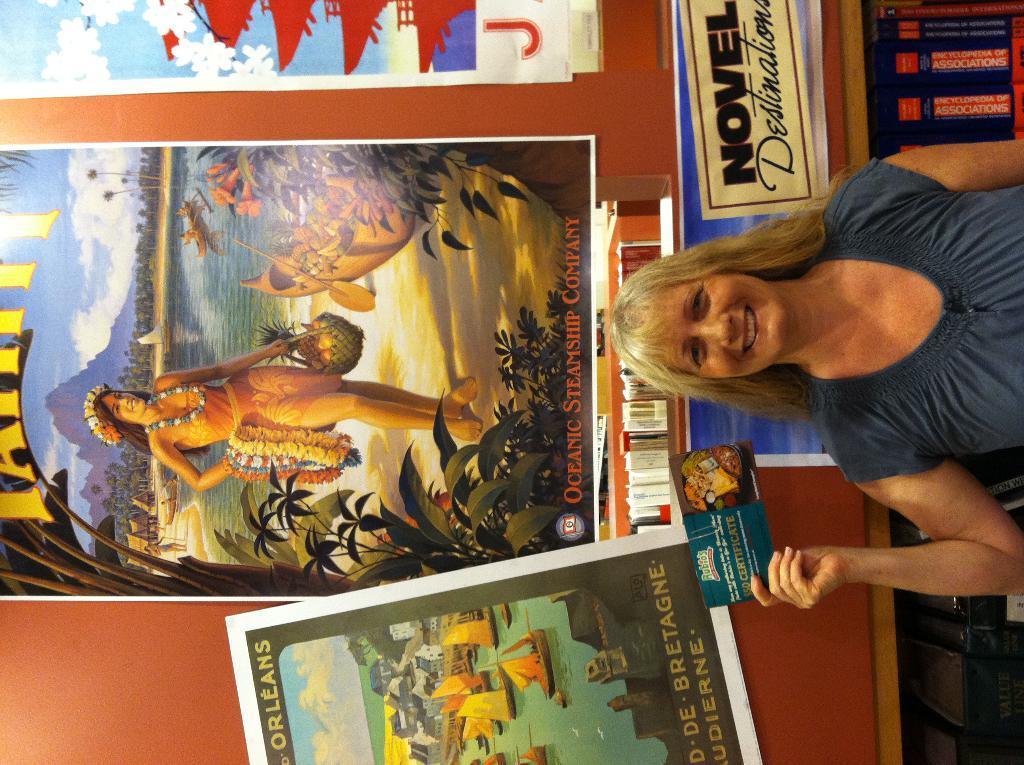Provide a one-sentence caption for the provided image. A woman holds a postcard in front of a display about novel destinations. 